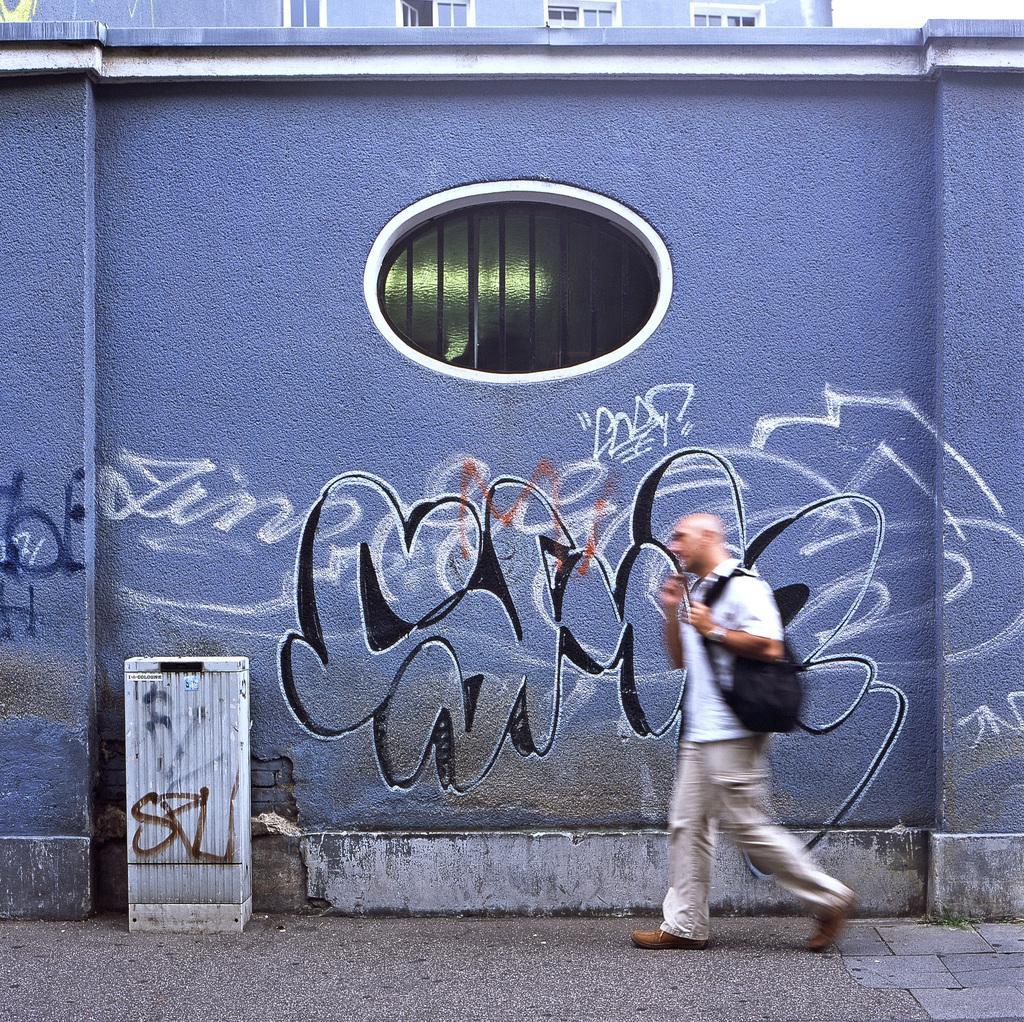Please provide a concise description of this image. In this image we can see a person wearing a backpack, walking on the pavement, also we can see a table, and a wall with some graffiti, also we can a building, and windows. 